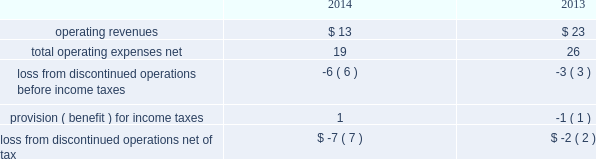During 2014 , the company closed on thirteen acquisitions of various regulated water and wastewater systems for a total aggregate purchase price of $ 9 .
Assets acquired , principally plant , totaled $ 17 .
Liabilities assumed totaled $ 8 , including $ 5 of contributions in aid of construction and assumed debt of $ 2 .
During 2013 , the company closed on fifteen acquisitions of various regulated water and wastewater systems for a total aggregate net purchase price of $ 24 .
Assets acquired , primarily utility plant , totaled $ 67 .
Liabilities assumed totaled $ 43 , including $ 26 of contributions in aid of construction and assumed debt of $ 13 .
Included in these totals was the company 2019s november 14 , 2013 acquisition of all of the capital stock of dale service corporation ( 201cdale 201d ) , a regulated wastewater utility company , for a total cash purchase price of $ 5 ( net of cash acquired of $ 7 ) , plus assumed liabilities .
The dale acquisition was accounted for as a business combination ; accordingly , operating results from november 14 , 2013 were included in the company 2019s results of operations .
The purchase price was allocated to the net tangible and intangible assets based upon their estimated fair values at the date of acquisition .
The company 2019s regulatory practice was followed whereby property , plant and equipment ( rate base ) was considered fair value for business combination purposes .
Similarly , regulatory assets and liabilities acquired were recorded at book value and are subject to regulatory approval where applicable .
The acquired debt was valued in a manner consistent with the company 2019s level 3 debt .
See note 17 2014fair value of financial instruments .
Non-cash assets acquired in the dale acquisition , primarily utility plant , totaled $ 41 ; liabilities assumed totaled $ 36 , including debt assumed of $ 13 and contributions of $ 19 .
Divestitures in november 2014 , the company completed the sale of terratec , previously included in the market-based businesses .
After post-close adjustments , net proceeds from the sale totaled $ 1 , and the company recorded a pretax loss on sale of $ 1 .
The table summarizes the operating results of discontinued operations presented in the accompanying consolidated statements of operations for the years ended december 31: .
The provision for income taxes of discontinued operations includes the recognition of tax expense related to the difference between the tax basis and book basis of assets upon the sales of terratec that resulted in taxable gains , since an election was made under section 338 ( h ) ( 10 ) of the internal revenue code to treat the sales as asset sales .
There were no assets or liabilities of discontinued operations in the accompanying consolidated balance sheets as of december 31 , 2015 and 2014. .
By how much did operating revenue decrease from 2013 to 2014? 
Computations: ((13 - 23) / 23)
Answer: -0.43478. 